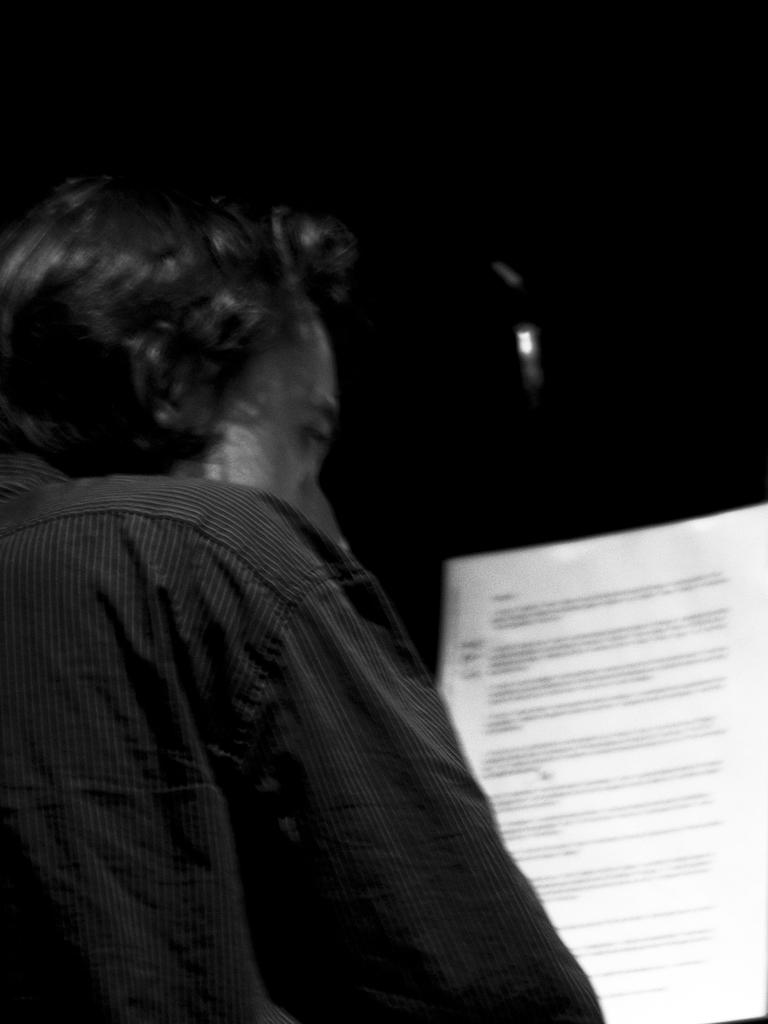Who or what is present in the image? There is a person in the image. What is the person doing in the image? The person is looking at a paper. What is the color scheme of the image? The image is in black and white color. Can you see any kitties playing with sticks in the image? There are no kitties or sticks present in the image. What type of support is the person using to read the paper in the image? The image does not show any specific support being used by the person to read the paper. 